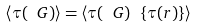<formula> <loc_0><loc_0><loc_500><loc_500>\left < \tau ( \ G ) \right > = \left < \tau ( \ G ) \ \{ \tau ( r ) \} \right ></formula> 